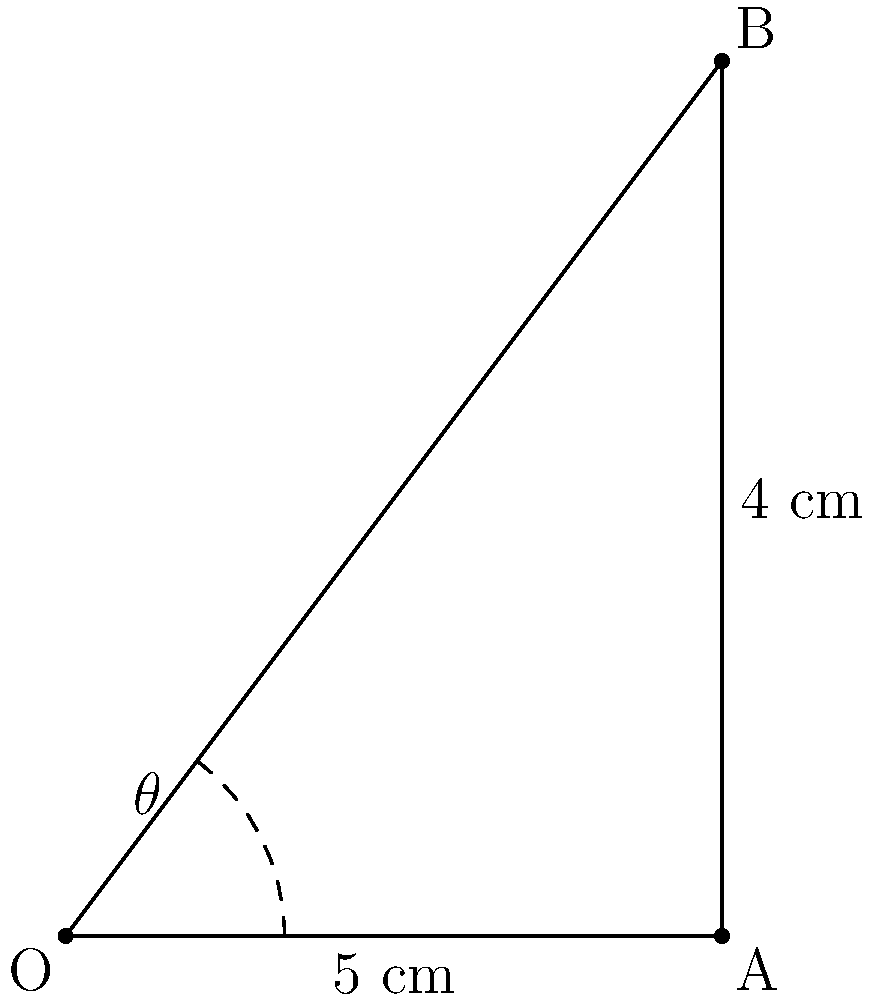During a birth, a photographer needs to calculate the angle of the baby's head as it crowns. The head can be modeled as a right triangle, where the visible part of the head (OA) is 5 cm, and the distance from the edge of the visible part to the top of the head (AB) is 4 cm. Calculate the angle $\theta$ (in degrees) that represents the crowning angle of the baby's head. To solve this problem, we'll use trigonometric functions in a right triangle:

1) In the right triangle OAB, we know:
   - The adjacent side (OA) = 5 cm
   - The opposite side (AB) = 4 cm

2) We need to find the angle $\theta$. We can use the tangent function:

   $$\tan(\theta) = \frac{\text{opposite}}{\text{adjacent}} = \frac{AB}{OA} = \frac{4}{5}$$

3) To find $\theta$, we need to use the inverse tangent (arctangent) function:

   $$\theta = \arctan(\frac{4}{5})$$

4) Using a calculator or programming function:

   $$\theta \approx 38.66^\circ$$

5) Rounding to two decimal places:

   $$\theta \approx 38.66^\circ$$

This angle represents the crowning angle of the baby's head during birth.
Answer: $38.66^\circ$ 